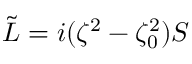<formula> <loc_0><loc_0><loc_500><loc_500>\begin{array} { r } { { \tilde { L } } = i ( \zeta ^ { 2 } - \zeta _ { 0 } ^ { 2 } ) S } \end{array}</formula> 